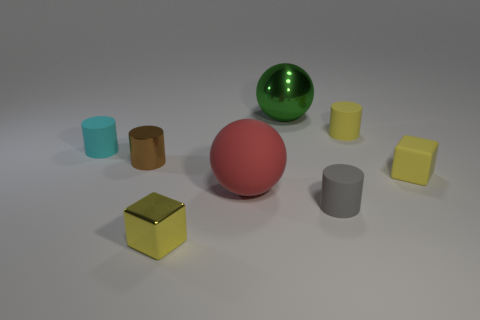Are there the same number of small things that are on the left side of the shiny cylinder and tiny brown shiny things to the right of the large green metallic ball?
Your answer should be compact. No. Is there any other thing that is the same size as the metal ball?
Your answer should be very brief. Yes. There is a red object that is the same shape as the green metallic thing; what is its material?
Provide a succinct answer. Rubber. Is there a large matte sphere behind the yellow block that is behind the large ball in front of the cyan object?
Provide a succinct answer. No. There is a tiny metal thing that is to the left of the yellow metallic object; is it the same shape as the small yellow rubber thing in front of the tiny cyan thing?
Provide a succinct answer. No. Are there more gray matte cylinders that are to the right of the small cyan cylinder than small gray matte cylinders?
Make the answer very short. No. How many objects are either large brown cylinders or small cylinders?
Your answer should be compact. 4. The metallic cylinder has what color?
Ensure brevity in your answer.  Brown. How many other things are there of the same color as the metallic block?
Keep it short and to the point. 2. There is a big matte thing; are there any gray matte objects left of it?
Keep it short and to the point. No. 